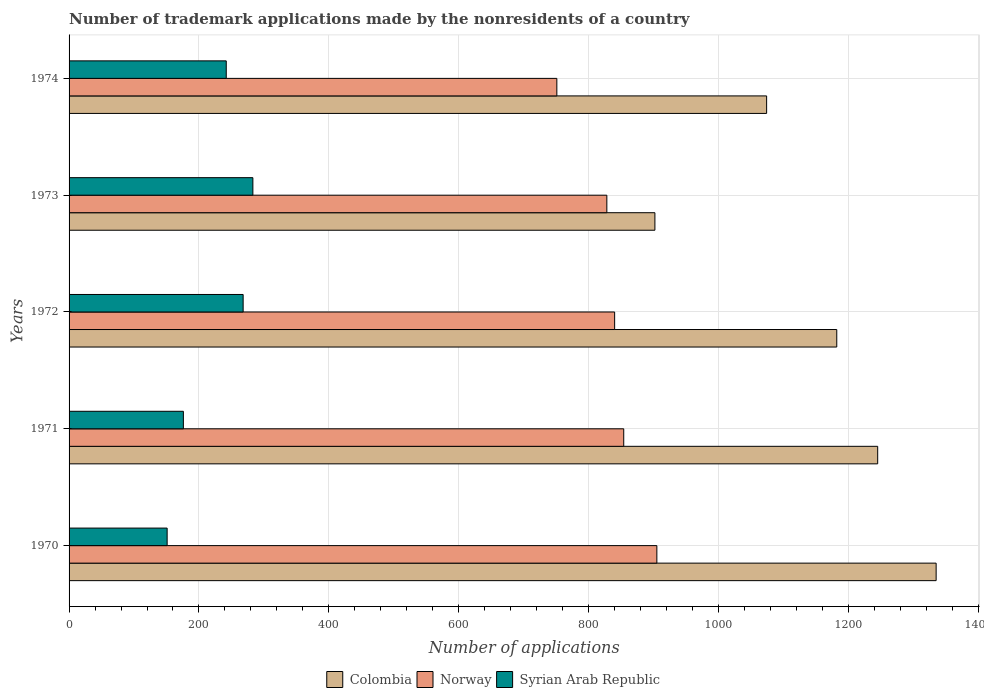Are the number of bars per tick equal to the number of legend labels?
Offer a terse response. Yes. How many bars are there on the 1st tick from the bottom?
Offer a very short reply. 3. What is the label of the 3rd group of bars from the top?
Ensure brevity in your answer.  1972. In how many cases, is the number of bars for a given year not equal to the number of legend labels?
Keep it short and to the point. 0. What is the number of trademark applications made by the nonresidents in Syrian Arab Republic in 1972?
Your response must be concise. 268. Across all years, what is the maximum number of trademark applications made by the nonresidents in Colombia?
Provide a succinct answer. 1335. Across all years, what is the minimum number of trademark applications made by the nonresidents in Norway?
Keep it short and to the point. 751. In which year was the number of trademark applications made by the nonresidents in Norway minimum?
Give a very brief answer. 1974. What is the total number of trademark applications made by the nonresidents in Syrian Arab Republic in the graph?
Ensure brevity in your answer.  1120. What is the difference between the number of trademark applications made by the nonresidents in Syrian Arab Republic in 1970 and that in 1971?
Give a very brief answer. -25. What is the difference between the number of trademark applications made by the nonresidents in Norway in 1971 and the number of trademark applications made by the nonresidents in Syrian Arab Republic in 1972?
Make the answer very short. 586. What is the average number of trademark applications made by the nonresidents in Norway per year?
Ensure brevity in your answer.  835.6. In the year 1970, what is the difference between the number of trademark applications made by the nonresidents in Syrian Arab Republic and number of trademark applications made by the nonresidents in Norway?
Make the answer very short. -754. In how many years, is the number of trademark applications made by the nonresidents in Syrian Arab Republic greater than 1120 ?
Make the answer very short. 0. What is the ratio of the number of trademark applications made by the nonresidents in Colombia in 1972 to that in 1973?
Make the answer very short. 1.31. What is the difference between the highest and the second highest number of trademark applications made by the nonresidents in Norway?
Offer a very short reply. 51. What is the difference between the highest and the lowest number of trademark applications made by the nonresidents in Colombia?
Provide a succinct answer. 433. What does the 1st bar from the bottom in 1970 represents?
Provide a short and direct response. Colombia. Is it the case that in every year, the sum of the number of trademark applications made by the nonresidents in Syrian Arab Republic and number of trademark applications made by the nonresidents in Colombia is greater than the number of trademark applications made by the nonresidents in Norway?
Ensure brevity in your answer.  Yes. How many bars are there?
Offer a terse response. 15. What is the difference between two consecutive major ticks on the X-axis?
Give a very brief answer. 200. Does the graph contain any zero values?
Your response must be concise. No. How are the legend labels stacked?
Give a very brief answer. Horizontal. What is the title of the graph?
Make the answer very short. Number of trademark applications made by the nonresidents of a country. Does "Mozambique" appear as one of the legend labels in the graph?
Provide a short and direct response. No. What is the label or title of the X-axis?
Offer a terse response. Number of applications. What is the Number of applications in Colombia in 1970?
Provide a succinct answer. 1335. What is the Number of applications of Norway in 1970?
Your answer should be very brief. 905. What is the Number of applications in Syrian Arab Republic in 1970?
Your response must be concise. 151. What is the Number of applications in Colombia in 1971?
Offer a very short reply. 1245. What is the Number of applications of Norway in 1971?
Your answer should be very brief. 854. What is the Number of applications of Syrian Arab Republic in 1971?
Give a very brief answer. 176. What is the Number of applications in Colombia in 1972?
Offer a terse response. 1182. What is the Number of applications in Norway in 1972?
Provide a short and direct response. 840. What is the Number of applications of Syrian Arab Republic in 1972?
Your answer should be compact. 268. What is the Number of applications in Colombia in 1973?
Offer a terse response. 902. What is the Number of applications in Norway in 1973?
Give a very brief answer. 828. What is the Number of applications of Syrian Arab Republic in 1973?
Your answer should be very brief. 283. What is the Number of applications of Colombia in 1974?
Your answer should be compact. 1074. What is the Number of applications of Norway in 1974?
Give a very brief answer. 751. What is the Number of applications of Syrian Arab Republic in 1974?
Your response must be concise. 242. Across all years, what is the maximum Number of applications of Colombia?
Your answer should be very brief. 1335. Across all years, what is the maximum Number of applications of Norway?
Keep it short and to the point. 905. Across all years, what is the maximum Number of applications in Syrian Arab Republic?
Your response must be concise. 283. Across all years, what is the minimum Number of applications of Colombia?
Your answer should be compact. 902. Across all years, what is the minimum Number of applications of Norway?
Make the answer very short. 751. Across all years, what is the minimum Number of applications of Syrian Arab Republic?
Provide a succinct answer. 151. What is the total Number of applications in Colombia in the graph?
Provide a short and direct response. 5738. What is the total Number of applications in Norway in the graph?
Ensure brevity in your answer.  4178. What is the total Number of applications of Syrian Arab Republic in the graph?
Ensure brevity in your answer.  1120. What is the difference between the Number of applications in Colombia in 1970 and that in 1971?
Your answer should be very brief. 90. What is the difference between the Number of applications of Syrian Arab Republic in 1970 and that in 1971?
Your response must be concise. -25. What is the difference between the Number of applications in Colombia in 1970 and that in 1972?
Your response must be concise. 153. What is the difference between the Number of applications of Syrian Arab Republic in 1970 and that in 1972?
Make the answer very short. -117. What is the difference between the Number of applications of Colombia in 1970 and that in 1973?
Provide a short and direct response. 433. What is the difference between the Number of applications in Syrian Arab Republic in 1970 and that in 1973?
Your response must be concise. -132. What is the difference between the Number of applications in Colombia in 1970 and that in 1974?
Provide a succinct answer. 261. What is the difference between the Number of applications in Norway in 1970 and that in 1974?
Provide a short and direct response. 154. What is the difference between the Number of applications of Syrian Arab Republic in 1970 and that in 1974?
Offer a very short reply. -91. What is the difference between the Number of applications of Norway in 1971 and that in 1972?
Your answer should be very brief. 14. What is the difference between the Number of applications in Syrian Arab Republic in 1971 and that in 1972?
Provide a succinct answer. -92. What is the difference between the Number of applications of Colombia in 1971 and that in 1973?
Your answer should be very brief. 343. What is the difference between the Number of applications in Norway in 1971 and that in 1973?
Give a very brief answer. 26. What is the difference between the Number of applications of Syrian Arab Republic in 1971 and that in 1973?
Offer a very short reply. -107. What is the difference between the Number of applications in Colombia in 1971 and that in 1974?
Make the answer very short. 171. What is the difference between the Number of applications in Norway in 1971 and that in 1974?
Your answer should be compact. 103. What is the difference between the Number of applications in Syrian Arab Republic in 1971 and that in 1974?
Make the answer very short. -66. What is the difference between the Number of applications in Colombia in 1972 and that in 1973?
Offer a very short reply. 280. What is the difference between the Number of applications of Syrian Arab Republic in 1972 and that in 1973?
Make the answer very short. -15. What is the difference between the Number of applications in Colombia in 1972 and that in 1974?
Your response must be concise. 108. What is the difference between the Number of applications in Norway in 1972 and that in 1974?
Your answer should be compact. 89. What is the difference between the Number of applications in Syrian Arab Republic in 1972 and that in 1974?
Offer a very short reply. 26. What is the difference between the Number of applications of Colombia in 1973 and that in 1974?
Your response must be concise. -172. What is the difference between the Number of applications in Norway in 1973 and that in 1974?
Offer a terse response. 77. What is the difference between the Number of applications of Colombia in 1970 and the Number of applications of Norway in 1971?
Keep it short and to the point. 481. What is the difference between the Number of applications in Colombia in 1970 and the Number of applications in Syrian Arab Republic in 1971?
Your answer should be compact. 1159. What is the difference between the Number of applications in Norway in 1970 and the Number of applications in Syrian Arab Republic in 1971?
Make the answer very short. 729. What is the difference between the Number of applications of Colombia in 1970 and the Number of applications of Norway in 1972?
Offer a very short reply. 495. What is the difference between the Number of applications in Colombia in 1970 and the Number of applications in Syrian Arab Republic in 1972?
Your response must be concise. 1067. What is the difference between the Number of applications of Norway in 1970 and the Number of applications of Syrian Arab Republic in 1972?
Your answer should be very brief. 637. What is the difference between the Number of applications in Colombia in 1970 and the Number of applications in Norway in 1973?
Make the answer very short. 507. What is the difference between the Number of applications in Colombia in 1970 and the Number of applications in Syrian Arab Republic in 1973?
Offer a very short reply. 1052. What is the difference between the Number of applications in Norway in 1970 and the Number of applications in Syrian Arab Republic in 1973?
Provide a succinct answer. 622. What is the difference between the Number of applications of Colombia in 1970 and the Number of applications of Norway in 1974?
Offer a terse response. 584. What is the difference between the Number of applications of Colombia in 1970 and the Number of applications of Syrian Arab Republic in 1974?
Keep it short and to the point. 1093. What is the difference between the Number of applications in Norway in 1970 and the Number of applications in Syrian Arab Republic in 1974?
Make the answer very short. 663. What is the difference between the Number of applications of Colombia in 1971 and the Number of applications of Norway in 1972?
Make the answer very short. 405. What is the difference between the Number of applications in Colombia in 1971 and the Number of applications in Syrian Arab Republic in 1972?
Ensure brevity in your answer.  977. What is the difference between the Number of applications in Norway in 1971 and the Number of applications in Syrian Arab Republic in 1972?
Give a very brief answer. 586. What is the difference between the Number of applications in Colombia in 1971 and the Number of applications in Norway in 1973?
Make the answer very short. 417. What is the difference between the Number of applications of Colombia in 1971 and the Number of applications of Syrian Arab Republic in 1973?
Make the answer very short. 962. What is the difference between the Number of applications of Norway in 1971 and the Number of applications of Syrian Arab Republic in 1973?
Offer a terse response. 571. What is the difference between the Number of applications in Colombia in 1971 and the Number of applications in Norway in 1974?
Provide a succinct answer. 494. What is the difference between the Number of applications in Colombia in 1971 and the Number of applications in Syrian Arab Republic in 1974?
Ensure brevity in your answer.  1003. What is the difference between the Number of applications of Norway in 1971 and the Number of applications of Syrian Arab Republic in 1974?
Offer a very short reply. 612. What is the difference between the Number of applications of Colombia in 1972 and the Number of applications of Norway in 1973?
Offer a very short reply. 354. What is the difference between the Number of applications of Colombia in 1972 and the Number of applications of Syrian Arab Republic in 1973?
Your answer should be compact. 899. What is the difference between the Number of applications of Norway in 1972 and the Number of applications of Syrian Arab Republic in 1973?
Give a very brief answer. 557. What is the difference between the Number of applications of Colombia in 1972 and the Number of applications of Norway in 1974?
Your answer should be compact. 431. What is the difference between the Number of applications of Colombia in 1972 and the Number of applications of Syrian Arab Republic in 1974?
Make the answer very short. 940. What is the difference between the Number of applications of Norway in 1972 and the Number of applications of Syrian Arab Republic in 1974?
Offer a terse response. 598. What is the difference between the Number of applications in Colombia in 1973 and the Number of applications in Norway in 1974?
Make the answer very short. 151. What is the difference between the Number of applications of Colombia in 1973 and the Number of applications of Syrian Arab Republic in 1974?
Ensure brevity in your answer.  660. What is the difference between the Number of applications in Norway in 1973 and the Number of applications in Syrian Arab Republic in 1974?
Keep it short and to the point. 586. What is the average Number of applications in Colombia per year?
Make the answer very short. 1147.6. What is the average Number of applications of Norway per year?
Ensure brevity in your answer.  835.6. What is the average Number of applications of Syrian Arab Republic per year?
Your response must be concise. 224. In the year 1970, what is the difference between the Number of applications in Colombia and Number of applications in Norway?
Your answer should be compact. 430. In the year 1970, what is the difference between the Number of applications of Colombia and Number of applications of Syrian Arab Republic?
Provide a succinct answer. 1184. In the year 1970, what is the difference between the Number of applications of Norway and Number of applications of Syrian Arab Republic?
Offer a very short reply. 754. In the year 1971, what is the difference between the Number of applications in Colombia and Number of applications in Norway?
Ensure brevity in your answer.  391. In the year 1971, what is the difference between the Number of applications in Colombia and Number of applications in Syrian Arab Republic?
Provide a short and direct response. 1069. In the year 1971, what is the difference between the Number of applications of Norway and Number of applications of Syrian Arab Republic?
Keep it short and to the point. 678. In the year 1972, what is the difference between the Number of applications in Colombia and Number of applications in Norway?
Your answer should be very brief. 342. In the year 1972, what is the difference between the Number of applications in Colombia and Number of applications in Syrian Arab Republic?
Offer a terse response. 914. In the year 1972, what is the difference between the Number of applications of Norway and Number of applications of Syrian Arab Republic?
Make the answer very short. 572. In the year 1973, what is the difference between the Number of applications of Colombia and Number of applications of Syrian Arab Republic?
Offer a terse response. 619. In the year 1973, what is the difference between the Number of applications of Norway and Number of applications of Syrian Arab Republic?
Offer a terse response. 545. In the year 1974, what is the difference between the Number of applications of Colombia and Number of applications of Norway?
Offer a very short reply. 323. In the year 1974, what is the difference between the Number of applications of Colombia and Number of applications of Syrian Arab Republic?
Your response must be concise. 832. In the year 1974, what is the difference between the Number of applications in Norway and Number of applications in Syrian Arab Republic?
Offer a terse response. 509. What is the ratio of the Number of applications of Colombia in 1970 to that in 1971?
Your answer should be compact. 1.07. What is the ratio of the Number of applications in Norway in 1970 to that in 1971?
Offer a very short reply. 1.06. What is the ratio of the Number of applications of Syrian Arab Republic in 1970 to that in 1971?
Offer a terse response. 0.86. What is the ratio of the Number of applications in Colombia in 1970 to that in 1972?
Keep it short and to the point. 1.13. What is the ratio of the Number of applications of Norway in 1970 to that in 1972?
Make the answer very short. 1.08. What is the ratio of the Number of applications in Syrian Arab Republic in 1970 to that in 1972?
Your answer should be very brief. 0.56. What is the ratio of the Number of applications in Colombia in 1970 to that in 1973?
Give a very brief answer. 1.48. What is the ratio of the Number of applications in Norway in 1970 to that in 1973?
Your response must be concise. 1.09. What is the ratio of the Number of applications of Syrian Arab Republic in 1970 to that in 1973?
Keep it short and to the point. 0.53. What is the ratio of the Number of applications in Colombia in 1970 to that in 1974?
Provide a succinct answer. 1.24. What is the ratio of the Number of applications of Norway in 1970 to that in 1974?
Make the answer very short. 1.21. What is the ratio of the Number of applications of Syrian Arab Republic in 1970 to that in 1974?
Provide a succinct answer. 0.62. What is the ratio of the Number of applications of Colombia in 1971 to that in 1972?
Keep it short and to the point. 1.05. What is the ratio of the Number of applications in Norway in 1971 to that in 1972?
Your response must be concise. 1.02. What is the ratio of the Number of applications in Syrian Arab Republic in 1971 to that in 1972?
Your answer should be compact. 0.66. What is the ratio of the Number of applications of Colombia in 1971 to that in 1973?
Your answer should be compact. 1.38. What is the ratio of the Number of applications of Norway in 1971 to that in 1973?
Provide a succinct answer. 1.03. What is the ratio of the Number of applications in Syrian Arab Republic in 1971 to that in 1973?
Provide a succinct answer. 0.62. What is the ratio of the Number of applications in Colombia in 1971 to that in 1974?
Make the answer very short. 1.16. What is the ratio of the Number of applications in Norway in 1971 to that in 1974?
Ensure brevity in your answer.  1.14. What is the ratio of the Number of applications in Syrian Arab Republic in 1971 to that in 1974?
Make the answer very short. 0.73. What is the ratio of the Number of applications in Colombia in 1972 to that in 1973?
Give a very brief answer. 1.31. What is the ratio of the Number of applications in Norway in 1972 to that in 1973?
Your answer should be compact. 1.01. What is the ratio of the Number of applications of Syrian Arab Republic in 1972 to that in 1973?
Your answer should be compact. 0.95. What is the ratio of the Number of applications of Colombia in 1972 to that in 1974?
Your answer should be compact. 1.1. What is the ratio of the Number of applications in Norway in 1972 to that in 1974?
Keep it short and to the point. 1.12. What is the ratio of the Number of applications of Syrian Arab Republic in 1972 to that in 1974?
Your answer should be very brief. 1.11. What is the ratio of the Number of applications of Colombia in 1973 to that in 1974?
Provide a short and direct response. 0.84. What is the ratio of the Number of applications in Norway in 1973 to that in 1974?
Offer a very short reply. 1.1. What is the ratio of the Number of applications in Syrian Arab Republic in 1973 to that in 1974?
Your answer should be compact. 1.17. What is the difference between the highest and the second highest Number of applications of Norway?
Ensure brevity in your answer.  51. What is the difference between the highest and the lowest Number of applications of Colombia?
Give a very brief answer. 433. What is the difference between the highest and the lowest Number of applications in Norway?
Provide a short and direct response. 154. What is the difference between the highest and the lowest Number of applications in Syrian Arab Republic?
Offer a very short reply. 132. 